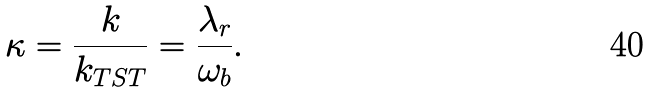<formula> <loc_0><loc_0><loc_500><loc_500>\kappa = \frac { k } { k _ { T S T } } = \frac { \lambda _ { r } } { \omega _ { b } } .</formula> 